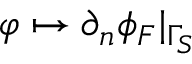<formula> <loc_0><loc_0><loc_500><loc_500>\varphi \mapsto \partial _ { n } \phi _ { F } | _ { \Gamma _ { S } }</formula> 